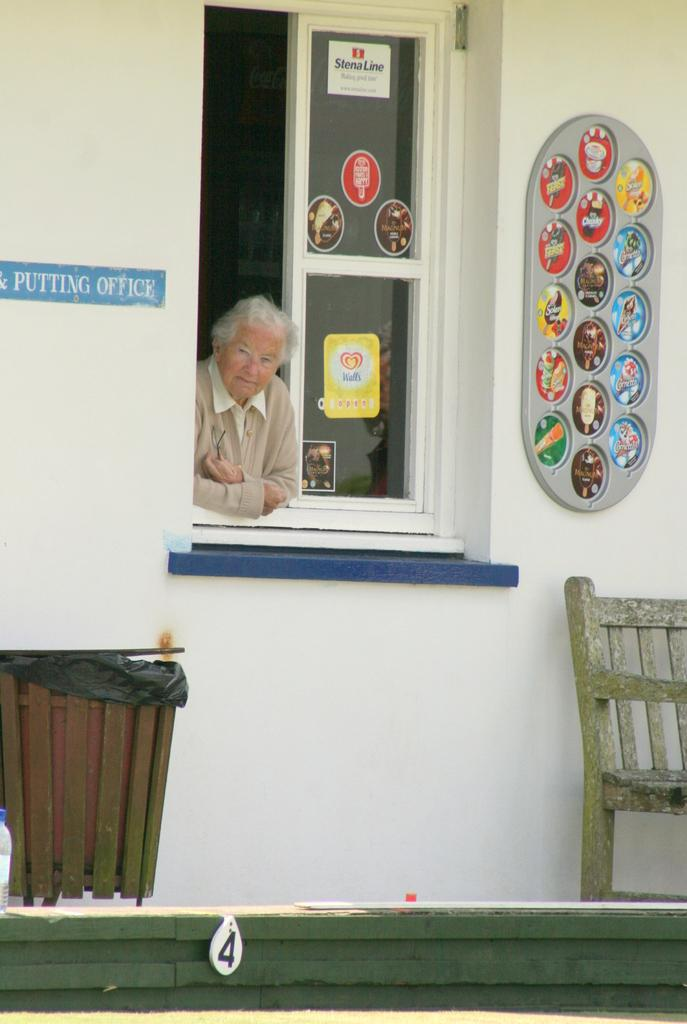What object is located at the bottom of the image? There is a dustbin at the bottom of the image. What is an unusual feature in the image? There is a chair on the fence in the image. What can be seen in the background of the image? There is a wall and a window in the background of the image. Is there any human presence in the image? Yes, there is a person in the background of the image. When was the image taken? The image was taken during the day. What type of pump is being used by the boy in the image? There is no boy or pump present in the image. 